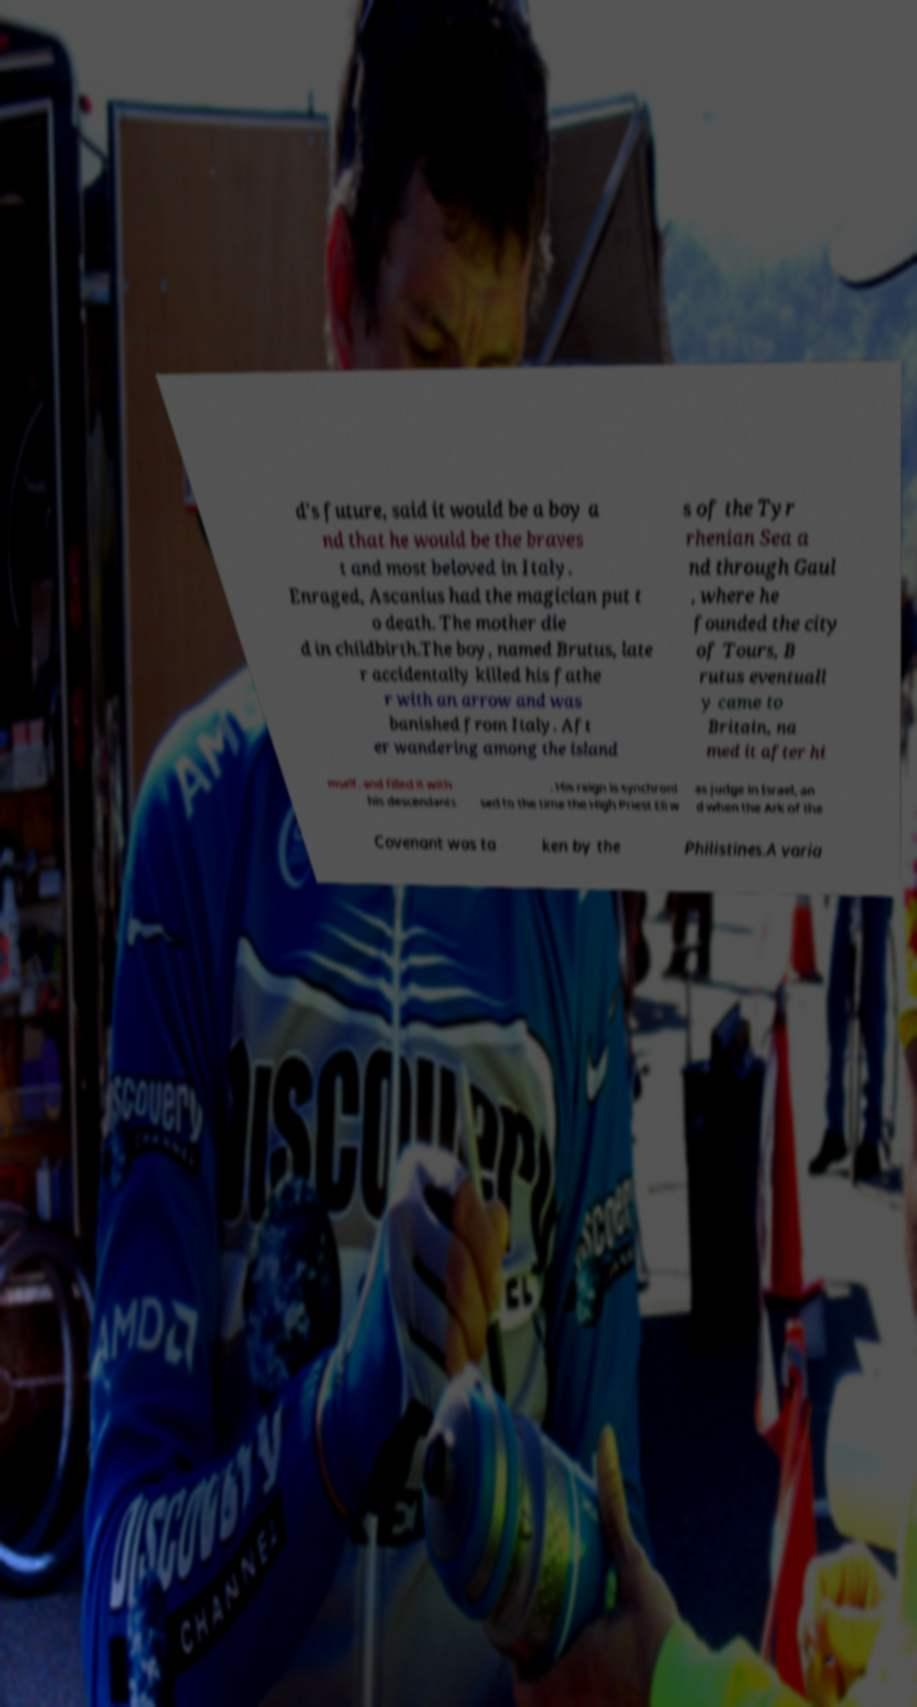There's text embedded in this image that I need extracted. Can you transcribe it verbatim? d's future, said it would be a boy a nd that he would be the braves t and most beloved in Italy. Enraged, Ascanius had the magician put t o death. The mother die d in childbirth.The boy, named Brutus, late r accidentally killed his fathe r with an arrow and was banished from Italy. Aft er wandering among the island s of the Tyr rhenian Sea a nd through Gaul , where he founded the city of Tours, B rutus eventuall y came to Britain, na med it after hi mself, and filled it with his descendants . His reign is synchroni sed to the time the High Priest Eli w as judge in Israel, an d when the Ark of the Covenant was ta ken by the Philistines.A varia 